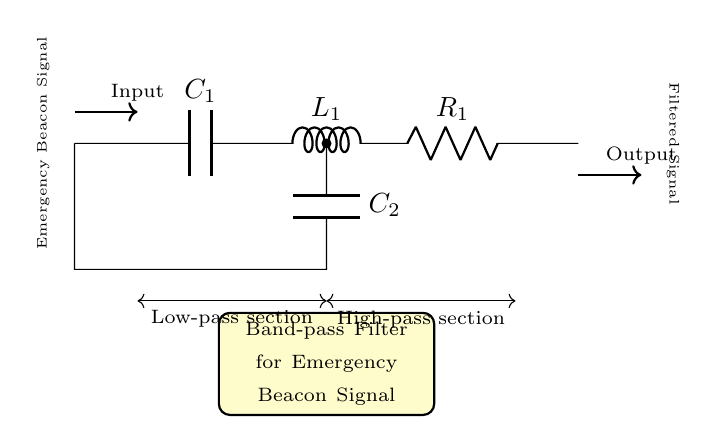What are the main components of this circuit? The circuit consists of two capacitors, one inductor, and one resistor, labeled as C1, L1, and R1, respectively.
Answer: capacitors, inductor, resistor What type of filter is this circuit designed to be? The circuit is designed as a band-pass filter, which is indicated by the label and the arrangement of the components to allow certain frequency ranges to pass while blocking others.
Answer: band-pass How many sections does this filter have? The filter has two sections: a low-pass section and a high-pass section, as indicated by the arrows and labels in the diagram.
Answer: two What is the purpose of the first capacitor in this filter? The first capacitor, labeled C1, is part of the low-pass section, allowing low-frequency signals to pass through while blocking high-frequency signals.
Answer: allow low frequencies What is the function of the resistor in this band-pass filter? The resistor, R1, is crucial in determining the bandwidth and gain of the filter, working with the inductor and capacitors to shape the frequency response.
Answer: determine gain Which type of signal does the circuit filter? The circuit filters emergency beacon signals, as explicitly mentioned in the labeled diagram where the input signal is described as such.
Answer: emergency beacon signal What does the output signal represent? The output signal represents the filtered version of the input, where only the desired frequency components of the emergency beacon signal are allowed through, while others are attenuated.
Answer: filtered signal 